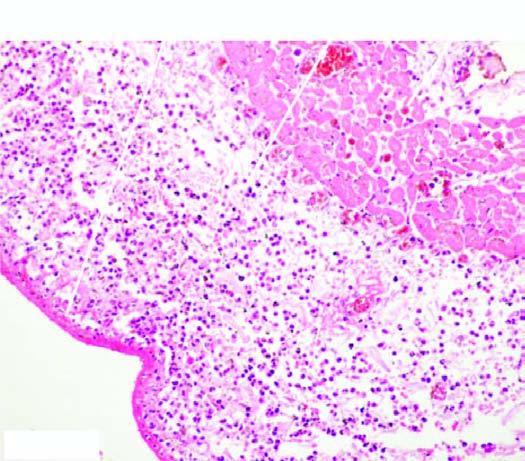do large cystic spaces lined by the flattened endothelial cells and containing lymph contain numerous inflammatory cells, chiefly pmns?
Answer the question using a single word or phrase. No 